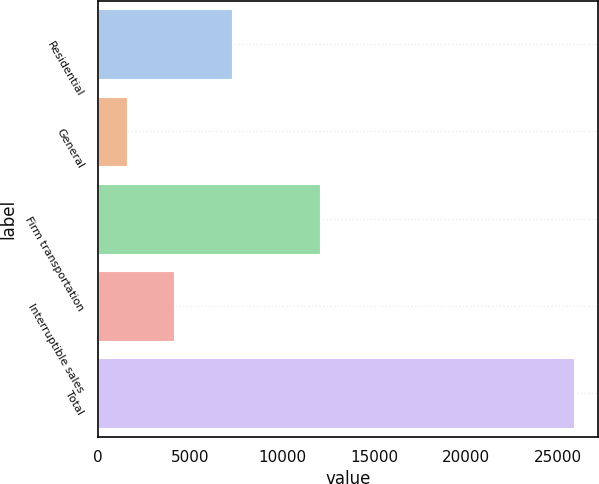<chart> <loc_0><loc_0><loc_500><loc_500><bar_chart><fcel>Residential<fcel>General<fcel>Firm transportation<fcel>Interruptible sales<fcel>Total<nl><fcel>7253<fcel>1555<fcel>12062<fcel>4118<fcel>25892<nl></chart> 